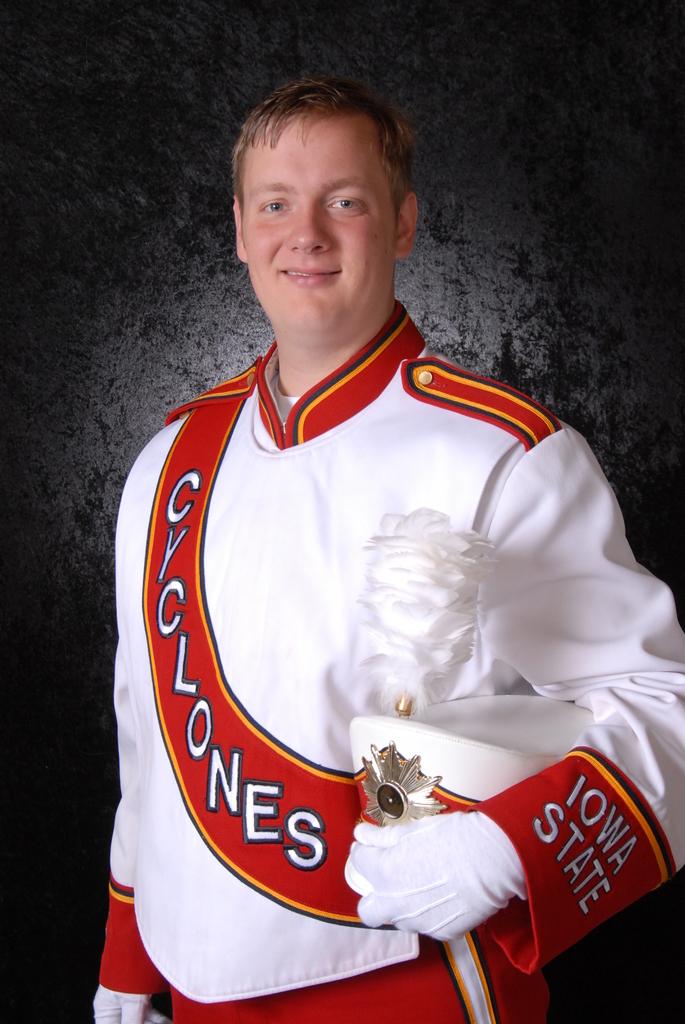What state is this man from?
Your answer should be compact. Iowa. 